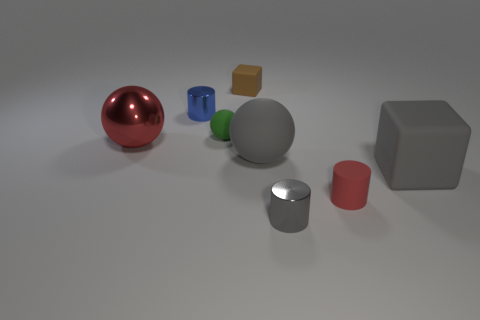Are the red object that is left of the green sphere and the red object that is in front of the big gray block made of the same material?
Your answer should be very brief. No. Are there any other small metallic objects that have the same shape as the tiny blue object?
Provide a short and direct response. Yes. What size is the cylinder that is on the right side of the small cylinder that is in front of the rubber object that is in front of the large gray matte cube?
Offer a terse response. Small. There is a cylinder that is the same color as the big block; what material is it?
Provide a short and direct response. Metal. How big is the gray metal thing?
Make the answer very short. Small. How many things are either rubber spheres or large gray objects that are to the right of the gray cylinder?
Your answer should be very brief. 3. How many other things are there of the same color as the large metallic object?
Ensure brevity in your answer.  1. Does the brown rubber thing have the same size as the cube that is in front of the shiny sphere?
Offer a terse response. No. Do the block that is in front of the brown object and the big matte ball have the same size?
Offer a terse response. Yes. What number of other objects are the same material as the tiny green sphere?
Give a very brief answer. 4. 